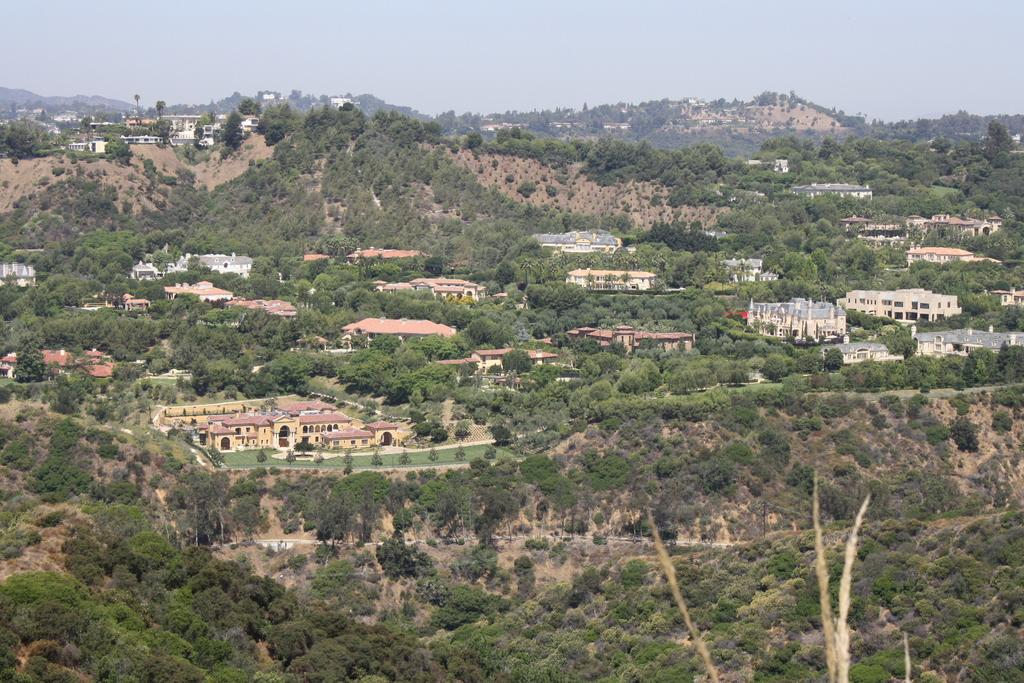What can be seen in the sky in the image? The sky is visible in the image. What type of natural landscape is present in the image? There are hills in the image. What type of man-made structures can be seen in the image? There are buildings and towers in the image. What type of vegetation is present in the image? Trees are present in the image. Can you tell me the name of the lawyer who is flying in the image? There is no lawyer or flying object present in the image. 